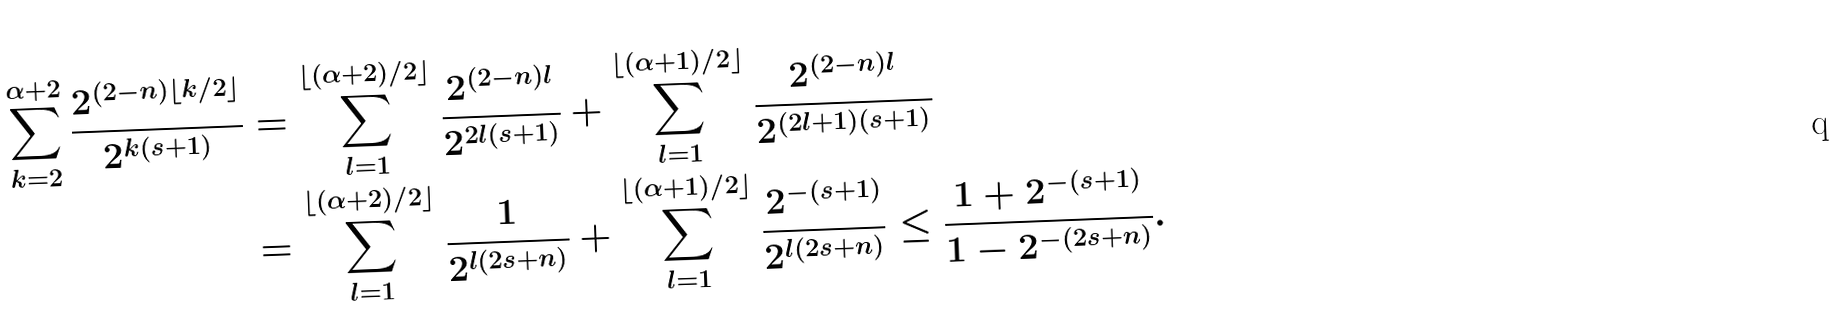<formula> <loc_0><loc_0><loc_500><loc_500>\sum _ { k = 2 } ^ { \alpha + 2 } \frac { 2 ^ { ( 2 - n ) \lfloor k / 2 \rfloor } } { 2 ^ { k ( s + 1 ) } } & = \sum _ { l = 1 } ^ { \lfloor ( \alpha + 2 ) / 2 \rfloor } \frac { 2 ^ { ( 2 - n ) l } } { 2 ^ { 2 l ( s + 1 ) } } + \sum _ { l = 1 } ^ { \lfloor ( \alpha + 1 ) / 2 \rfloor } \frac { 2 ^ { ( 2 - n ) l } } { 2 ^ { ( 2 l + 1 ) ( s + 1 ) } } \\ & = \sum _ { l = 1 } ^ { \lfloor ( \alpha + 2 ) / 2 \rfloor } \frac { 1 } { 2 ^ { l ( 2 s + n ) } } + \sum _ { l = 1 } ^ { \lfloor ( \alpha + 1 ) / 2 \rfloor } \frac { 2 ^ { - ( s + 1 ) } } { 2 ^ { l ( 2 s + n ) } } \leq \frac { 1 + 2 ^ { - ( s + 1 ) } } { 1 - 2 ^ { - ( 2 s + n ) } } .</formula> 